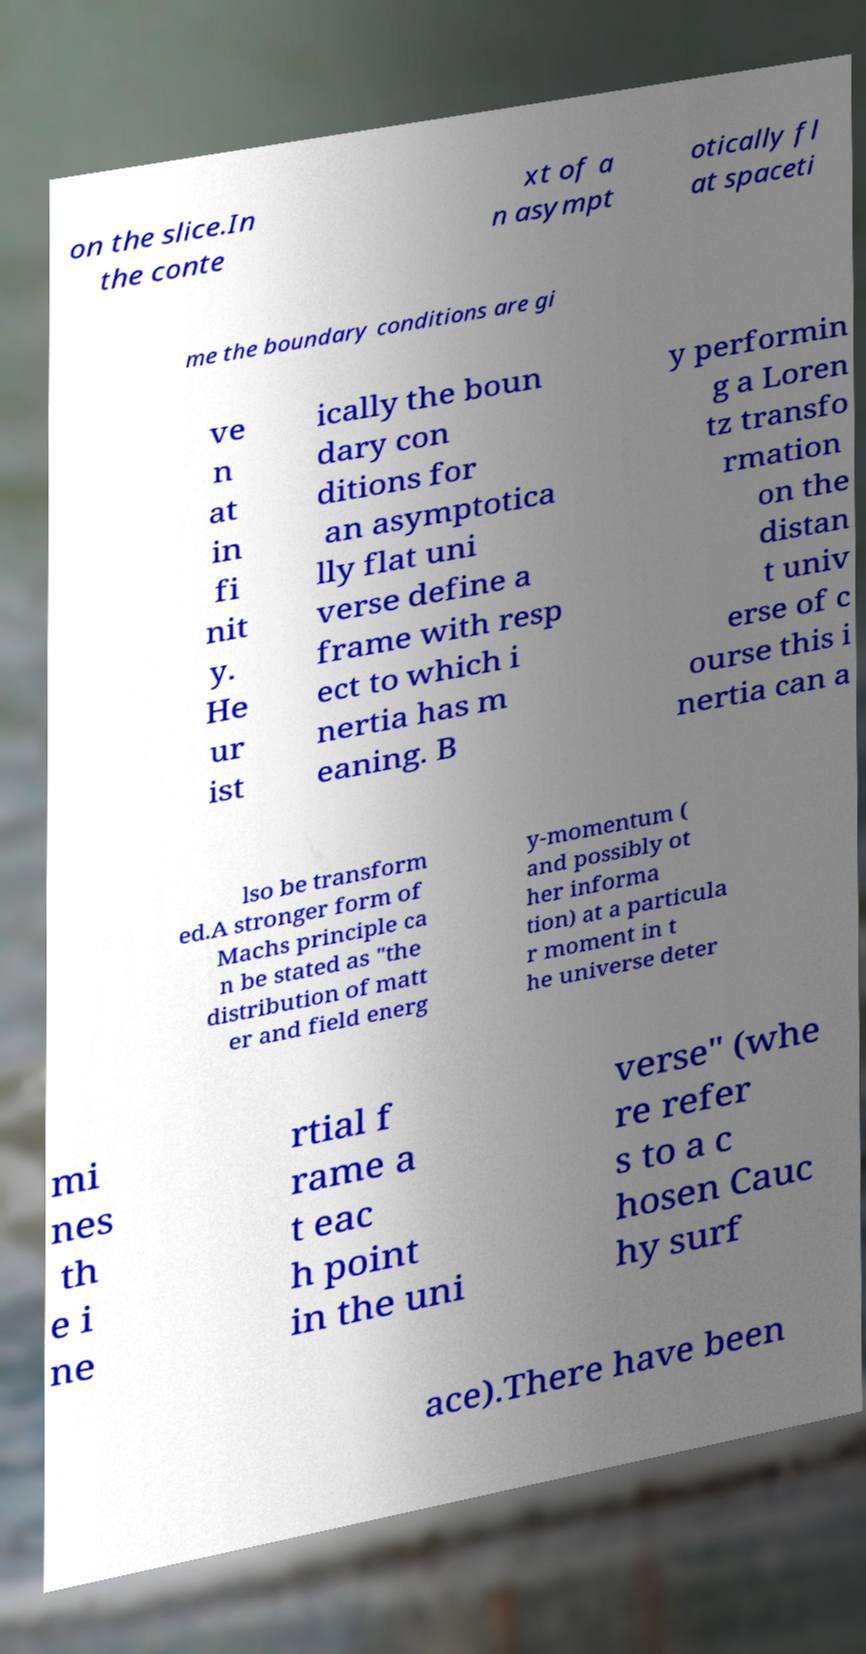Please read and relay the text visible in this image. What does it say? on the slice.In the conte xt of a n asympt otically fl at spaceti me the boundary conditions are gi ve n at in fi nit y. He ur ist ically the boun dary con ditions for an asymptotica lly flat uni verse define a frame with resp ect to which i nertia has m eaning. B y performin g a Loren tz transfo rmation on the distan t univ erse of c ourse this i nertia can a lso be transform ed.A stronger form of Machs principle ca n be stated as "the distribution of matt er and field energ y-momentum ( and possibly ot her informa tion) at a particula r moment in t he universe deter mi nes th e i ne rtial f rame a t eac h point in the uni verse" (whe re refer s to a c hosen Cauc hy surf ace).There have been 